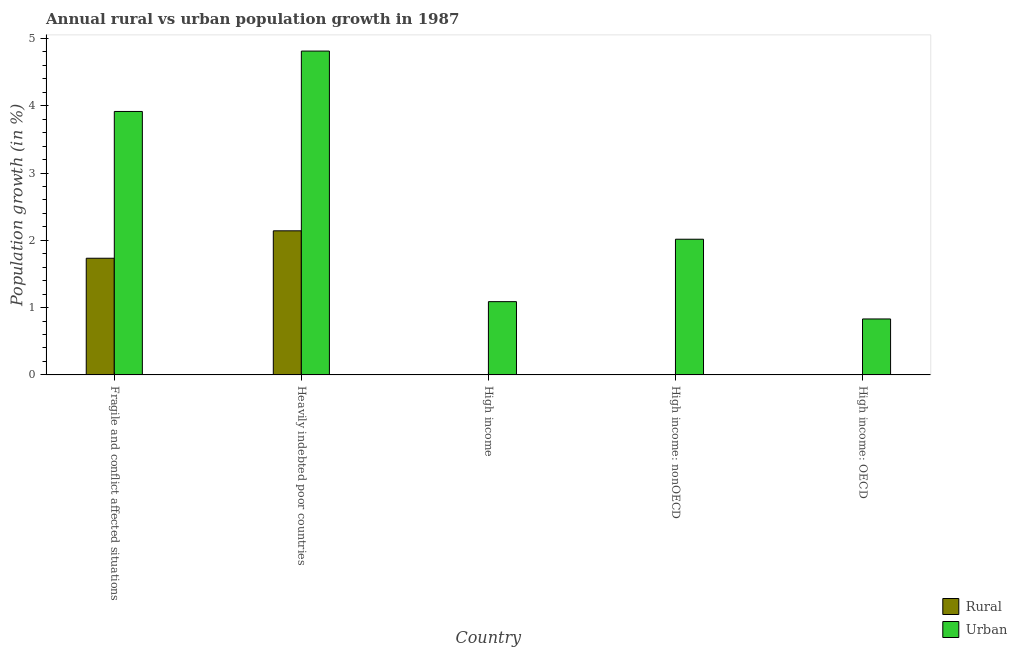How many different coloured bars are there?
Make the answer very short. 2. Are the number of bars on each tick of the X-axis equal?
Your response must be concise. No. How many bars are there on the 5th tick from the right?
Ensure brevity in your answer.  2. What is the label of the 3rd group of bars from the left?
Make the answer very short. High income. In how many cases, is the number of bars for a given country not equal to the number of legend labels?
Provide a succinct answer. 3. What is the urban population growth in High income: OECD?
Offer a very short reply. 0.83. Across all countries, what is the maximum rural population growth?
Provide a succinct answer. 2.14. Across all countries, what is the minimum urban population growth?
Provide a succinct answer. 0.83. In which country was the rural population growth maximum?
Provide a short and direct response. Heavily indebted poor countries. What is the total urban population growth in the graph?
Your answer should be very brief. 12.66. What is the difference between the urban population growth in High income and that in High income: OECD?
Your answer should be very brief. 0.26. What is the difference between the urban population growth in High income: OECD and the rural population growth in High income: nonOECD?
Ensure brevity in your answer.  0.83. What is the average rural population growth per country?
Your answer should be compact. 0.78. What is the difference between the rural population growth and urban population growth in Heavily indebted poor countries?
Your response must be concise. -2.67. What is the ratio of the urban population growth in Heavily indebted poor countries to that in High income?
Keep it short and to the point. 4.42. What is the difference between the highest and the second highest urban population growth?
Your response must be concise. 0.9. What is the difference between the highest and the lowest rural population growth?
Your answer should be compact. 2.14. How many bars are there?
Make the answer very short. 7. What is the difference between two consecutive major ticks on the Y-axis?
Provide a short and direct response. 1. Does the graph contain any zero values?
Offer a terse response. Yes. Does the graph contain grids?
Your answer should be compact. No. Where does the legend appear in the graph?
Ensure brevity in your answer.  Bottom right. How are the legend labels stacked?
Provide a succinct answer. Vertical. What is the title of the graph?
Offer a very short reply. Annual rural vs urban population growth in 1987. What is the label or title of the X-axis?
Ensure brevity in your answer.  Country. What is the label or title of the Y-axis?
Your response must be concise. Population growth (in %). What is the Population growth (in %) of Rural in Fragile and conflict affected situations?
Your answer should be very brief. 1.73. What is the Population growth (in %) in Urban  in Fragile and conflict affected situations?
Provide a succinct answer. 3.92. What is the Population growth (in %) in Rural in Heavily indebted poor countries?
Provide a short and direct response. 2.14. What is the Population growth (in %) of Urban  in Heavily indebted poor countries?
Your response must be concise. 4.81. What is the Population growth (in %) in Urban  in High income?
Ensure brevity in your answer.  1.09. What is the Population growth (in %) of Urban  in High income: nonOECD?
Offer a terse response. 2.02. What is the Population growth (in %) in Urban  in High income: OECD?
Keep it short and to the point. 0.83. Across all countries, what is the maximum Population growth (in %) in Rural?
Keep it short and to the point. 2.14. Across all countries, what is the maximum Population growth (in %) of Urban ?
Provide a succinct answer. 4.81. Across all countries, what is the minimum Population growth (in %) in Urban ?
Give a very brief answer. 0.83. What is the total Population growth (in %) in Rural in the graph?
Give a very brief answer. 3.88. What is the total Population growth (in %) in Urban  in the graph?
Ensure brevity in your answer.  12.66. What is the difference between the Population growth (in %) of Rural in Fragile and conflict affected situations and that in Heavily indebted poor countries?
Ensure brevity in your answer.  -0.41. What is the difference between the Population growth (in %) in Urban  in Fragile and conflict affected situations and that in Heavily indebted poor countries?
Ensure brevity in your answer.  -0.9. What is the difference between the Population growth (in %) in Urban  in Fragile and conflict affected situations and that in High income?
Ensure brevity in your answer.  2.83. What is the difference between the Population growth (in %) of Urban  in Fragile and conflict affected situations and that in High income: nonOECD?
Make the answer very short. 1.9. What is the difference between the Population growth (in %) in Urban  in Fragile and conflict affected situations and that in High income: OECD?
Your answer should be very brief. 3.08. What is the difference between the Population growth (in %) of Urban  in Heavily indebted poor countries and that in High income?
Your answer should be compact. 3.72. What is the difference between the Population growth (in %) of Urban  in Heavily indebted poor countries and that in High income: nonOECD?
Provide a succinct answer. 2.8. What is the difference between the Population growth (in %) in Urban  in Heavily indebted poor countries and that in High income: OECD?
Give a very brief answer. 3.98. What is the difference between the Population growth (in %) in Urban  in High income and that in High income: nonOECD?
Your answer should be very brief. -0.93. What is the difference between the Population growth (in %) in Urban  in High income and that in High income: OECD?
Offer a terse response. 0.26. What is the difference between the Population growth (in %) in Urban  in High income: nonOECD and that in High income: OECD?
Offer a very short reply. 1.19. What is the difference between the Population growth (in %) in Rural in Fragile and conflict affected situations and the Population growth (in %) in Urban  in Heavily indebted poor countries?
Give a very brief answer. -3.08. What is the difference between the Population growth (in %) in Rural in Fragile and conflict affected situations and the Population growth (in %) in Urban  in High income?
Provide a short and direct response. 0.65. What is the difference between the Population growth (in %) in Rural in Fragile and conflict affected situations and the Population growth (in %) in Urban  in High income: nonOECD?
Give a very brief answer. -0.28. What is the difference between the Population growth (in %) of Rural in Fragile and conflict affected situations and the Population growth (in %) of Urban  in High income: OECD?
Offer a terse response. 0.9. What is the difference between the Population growth (in %) of Rural in Heavily indebted poor countries and the Population growth (in %) of Urban  in High income?
Your answer should be compact. 1.05. What is the difference between the Population growth (in %) of Rural in Heavily indebted poor countries and the Population growth (in %) of Urban  in High income: nonOECD?
Make the answer very short. 0.12. What is the difference between the Population growth (in %) of Rural in Heavily indebted poor countries and the Population growth (in %) of Urban  in High income: OECD?
Keep it short and to the point. 1.31. What is the average Population growth (in %) in Rural per country?
Your answer should be compact. 0.78. What is the average Population growth (in %) of Urban  per country?
Ensure brevity in your answer.  2.53. What is the difference between the Population growth (in %) of Rural and Population growth (in %) of Urban  in Fragile and conflict affected situations?
Give a very brief answer. -2.18. What is the difference between the Population growth (in %) of Rural and Population growth (in %) of Urban  in Heavily indebted poor countries?
Ensure brevity in your answer.  -2.67. What is the ratio of the Population growth (in %) in Rural in Fragile and conflict affected situations to that in Heavily indebted poor countries?
Offer a terse response. 0.81. What is the ratio of the Population growth (in %) in Urban  in Fragile and conflict affected situations to that in Heavily indebted poor countries?
Provide a short and direct response. 0.81. What is the ratio of the Population growth (in %) of Urban  in Fragile and conflict affected situations to that in High income?
Provide a succinct answer. 3.6. What is the ratio of the Population growth (in %) in Urban  in Fragile and conflict affected situations to that in High income: nonOECD?
Offer a very short reply. 1.94. What is the ratio of the Population growth (in %) of Urban  in Fragile and conflict affected situations to that in High income: OECD?
Offer a terse response. 4.71. What is the ratio of the Population growth (in %) of Urban  in Heavily indebted poor countries to that in High income?
Offer a very short reply. 4.42. What is the ratio of the Population growth (in %) in Urban  in Heavily indebted poor countries to that in High income: nonOECD?
Make the answer very short. 2.39. What is the ratio of the Population growth (in %) of Urban  in Heavily indebted poor countries to that in High income: OECD?
Your answer should be compact. 5.79. What is the ratio of the Population growth (in %) in Urban  in High income to that in High income: nonOECD?
Your response must be concise. 0.54. What is the ratio of the Population growth (in %) in Urban  in High income to that in High income: OECD?
Make the answer very short. 1.31. What is the ratio of the Population growth (in %) of Urban  in High income: nonOECD to that in High income: OECD?
Provide a succinct answer. 2.42. What is the difference between the highest and the second highest Population growth (in %) in Urban ?
Ensure brevity in your answer.  0.9. What is the difference between the highest and the lowest Population growth (in %) in Rural?
Offer a very short reply. 2.14. What is the difference between the highest and the lowest Population growth (in %) of Urban ?
Offer a very short reply. 3.98. 